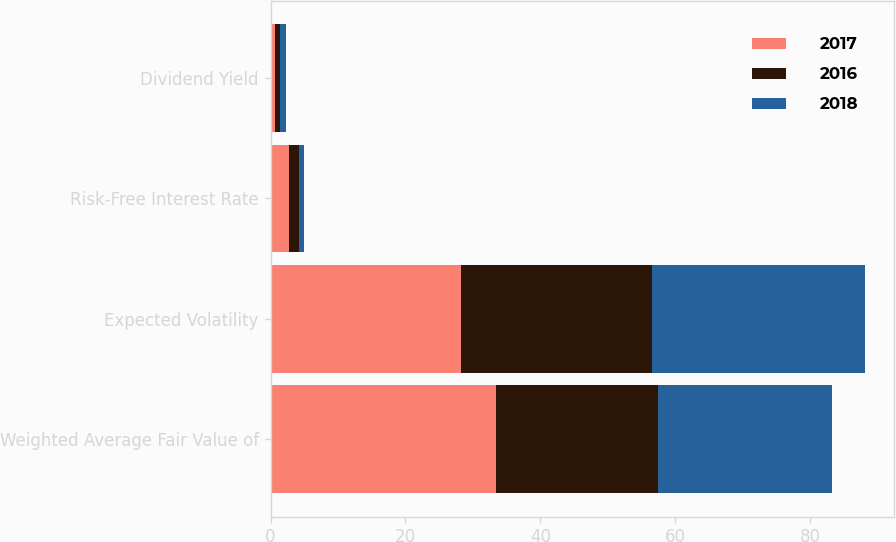<chart> <loc_0><loc_0><loc_500><loc_500><stacked_bar_chart><ecel><fcel>Weighted Average Fair Value of<fcel>Expected Volatility<fcel>Risk-Free Interest Rate<fcel>Dividend Yield<nl><fcel>2017<fcel>33.46<fcel>28.23<fcel>2.68<fcel>0.72<nl><fcel>2016<fcel>23.95<fcel>28.28<fcel>1.52<fcel>0.75<nl><fcel>2018<fcel>25.78<fcel>31.54<fcel>0.78<fcel>0.76<nl></chart> 